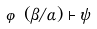Convert formula to latex. <formula><loc_0><loc_0><loc_500><loc_500>\varphi ( \beta / \alpha ) \vdash \psi</formula> 